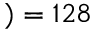<formula> <loc_0><loc_0><loc_500><loc_500>) = 1 2 8</formula> 